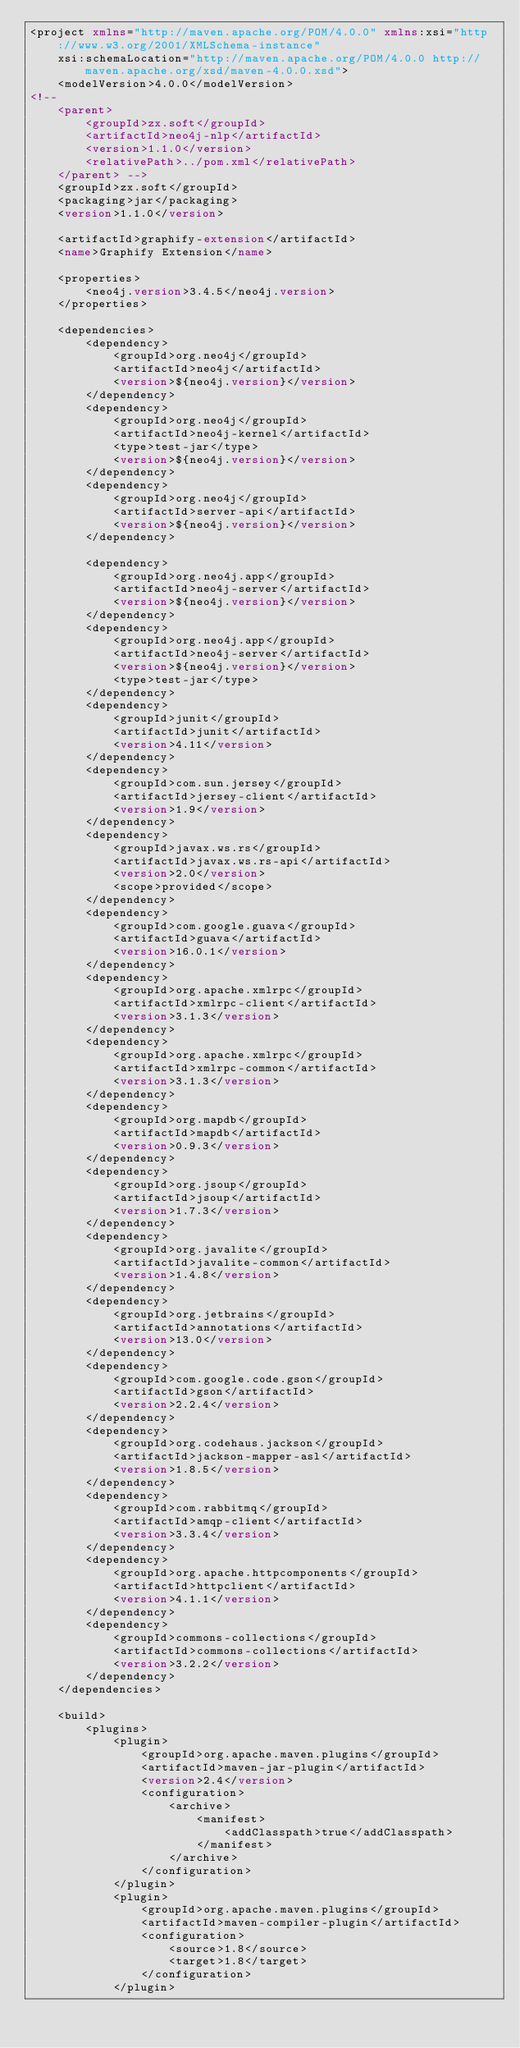Convert code to text. <code><loc_0><loc_0><loc_500><loc_500><_XML_><project xmlns="http://maven.apache.org/POM/4.0.0" xmlns:xsi="http://www.w3.org/2001/XMLSchema-instance"
	xsi:schemaLocation="http://maven.apache.org/POM/4.0.0 http://maven.apache.org/xsd/maven-4.0.0.xsd">
	<modelVersion>4.0.0</modelVersion>
<!-- 
	<parent>
		<groupId>zx.soft</groupId>
		<artifactId>neo4j-nlp</artifactId>
		<version>1.1.0</version>
		<relativePath>../pom.xml</relativePath>
	</parent> -->
	<groupId>zx.soft</groupId>
	<packaging>jar</packaging>
	<version>1.1.0</version>

	<artifactId>graphify-extension</artifactId>
	<name>Graphify Extension</name>

	<properties>
		<neo4j.version>3.4.5</neo4j.version>
	</properties>

	<dependencies>
		<dependency>
			<groupId>org.neo4j</groupId>
			<artifactId>neo4j</artifactId>
			<version>${neo4j.version}</version>
		</dependency>
		<dependency>
			<groupId>org.neo4j</groupId>
			<artifactId>neo4j-kernel</artifactId>
			<type>test-jar</type>
			<version>${neo4j.version}</version>
		</dependency>
		<dependency>
			<groupId>org.neo4j</groupId>
			<artifactId>server-api</artifactId>
			<version>${neo4j.version}</version>
		</dependency>
		
		<dependency>
			<groupId>org.neo4j.app</groupId>
			<artifactId>neo4j-server</artifactId>
			<version>${neo4j.version}</version>
		</dependency>
		<dependency>
			<groupId>org.neo4j.app</groupId>
			<artifactId>neo4j-server</artifactId>
			<version>${neo4j.version}</version>
			<type>test-jar</type>
		</dependency>
		<dependency>
			<groupId>junit</groupId>
			<artifactId>junit</artifactId>
			<version>4.11</version>
		</dependency>
		<dependency>
			<groupId>com.sun.jersey</groupId>
			<artifactId>jersey-client</artifactId>
			<version>1.9</version>
		</dependency>
		<dependency>
			<groupId>javax.ws.rs</groupId>
			<artifactId>javax.ws.rs-api</artifactId>
			<version>2.0</version>
			<scope>provided</scope>
		</dependency>
		<dependency>
			<groupId>com.google.guava</groupId>
			<artifactId>guava</artifactId>
			<version>16.0.1</version>
		</dependency>
		<dependency>
			<groupId>org.apache.xmlrpc</groupId>
			<artifactId>xmlrpc-client</artifactId>
			<version>3.1.3</version>
		</dependency>
		<dependency>
			<groupId>org.apache.xmlrpc</groupId>
			<artifactId>xmlrpc-common</artifactId>
			<version>3.1.3</version>
		</dependency>
		<dependency>
			<groupId>org.mapdb</groupId>
			<artifactId>mapdb</artifactId>
			<version>0.9.3</version>
		</dependency>
		<dependency>
			<groupId>org.jsoup</groupId>
			<artifactId>jsoup</artifactId>
			<version>1.7.3</version>
		</dependency>
		<dependency>
			<groupId>org.javalite</groupId>
			<artifactId>javalite-common</artifactId>
			<version>1.4.8</version>
		</dependency>
		<dependency>
			<groupId>org.jetbrains</groupId>
			<artifactId>annotations</artifactId>
			<version>13.0</version>
		</dependency>
		<dependency>
			<groupId>com.google.code.gson</groupId>
			<artifactId>gson</artifactId>
			<version>2.2.4</version>
		</dependency>
		<dependency>
			<groupId>org.codehaus.jackson</groupId>
			<artifactId>jackson-mapper-asl</artifactId>
			<version>1.8.5</version>
		</dependency>
		<dependency>
			<groupId>com.rabbitmq</groupId>
			<artifactId>amqp-client</artifactId>
			<version>3.3.4</version>
		</dependency>
		<dependency>
			<groupId>org.apache.httpcomponents</groupId>
			<artifactId>httpclient</artifactId>
			<version>4.1.1</version>
		</dependency>
		<dependency>
			<groupId>commons-collections</groupId>
			<artifactId>commons-collections</artifactId>
			<version>3.2.2</version>
		</dependency>
	</dependencies>

	<build>
		<plugins>
			<plugin>
                <groupId>org.apache.maven.plugins</groupId>
                <artifactId>maven-jar-plugin</artifactId>
                <version>2.4</version>
                <configuration>
                    <archive>
                        <manifest>
                            <addClasspath>true</addClasspath>
                        </manifest>
                    </archive>
                </configuration>
            </plugin>
			<plugin>
				<groupId>org.apache.maven.plugins</groupId>
				<artifactId>maven-compiler-plugin</artifactId>
				<configuration>
					<source>1.8</source>
					<target>1.8</target>
				</configuration>
			</plugin></code> 